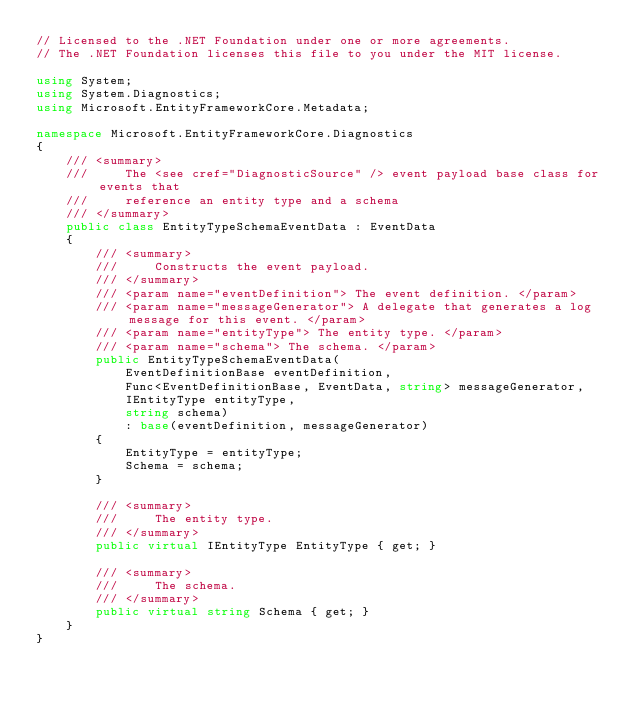Convert code to text. <code><loc_0><loc_0><loc_500><loc_500><_C#_>// Licensed to the .NET Foundation under one or more agreements.
// The .NET Foundation licenses this file to you under the MIT license.

using System;
using System.Diagnostics;
using Microsoft.EntityFrameworkCore.Metadata;

namespace Microsoft.EntityFrameworkCore.Diagnostics
{
    /// <summary>
    ///     The <see cref="DiagnosticSource" /> event payload base class for events that
    ///     reference an entity type and a schema
    /// </summary>
    public class EntityTypeSchemaEventData : EventData
    {
        /// <summary>
        ///     Constructs the event payload.
        /// </summary>
        /// <param name="eventDefinition"> The event definition. </param>
        /// <param name="messageGenerator"> A delegate that generates a log message for this event. </param>
        /// <param name="entityType"> The entity type. </param>
        /// <param name="schema"> The schema. </param>
        public EntityTypeSchemaEventData(
            EventDefinitionBase eventDefinition,
            Func<EventDefinitionBase, EventData, string> messageGenerator,
            IEntityType entityType,
            string schema)
            : base(eventDefinition, messageGenerator)
        {
            EntityType = entityType;
            Schema = schema;
        }

        /// <summary>
        ///     The entity type.
        /// </summary>
        public virtual IEntityType EntityType { get; }

        /// <summary>
        ///     The schema.
        /// </summary>
        public virtual string Schema { get; }
    }
}
</code> 